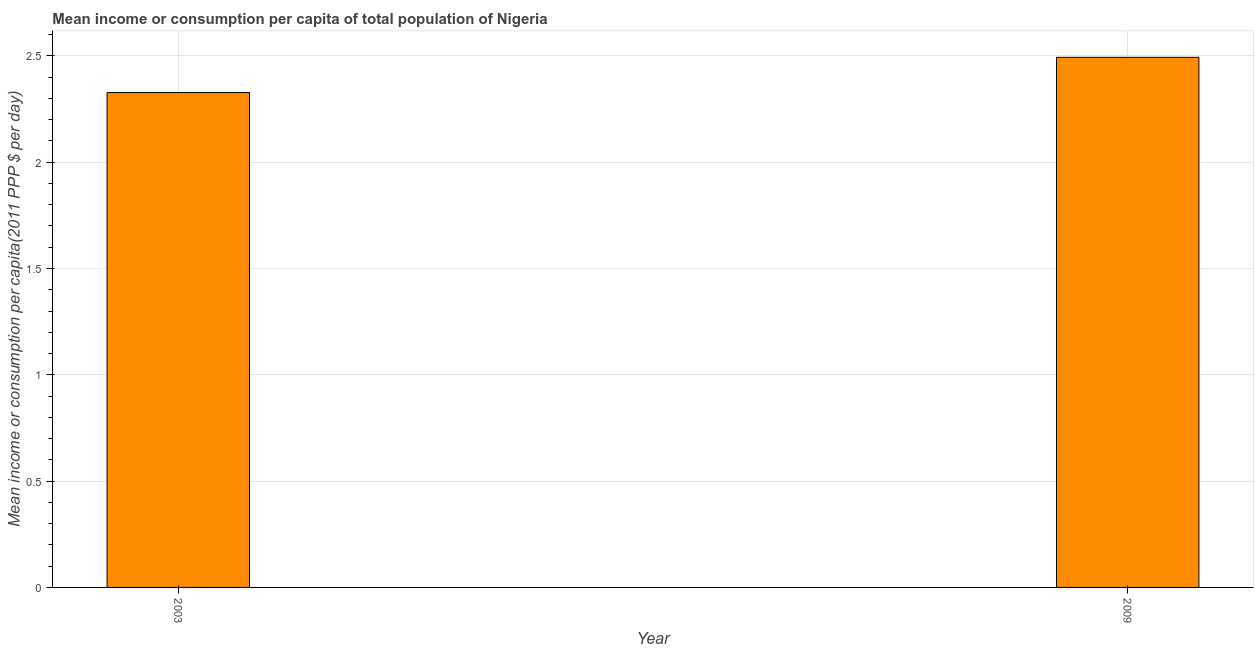What is the title of the graph?
Offer a terse response. Mean income or consumption per capita of total population of Nigeria. What is the label or title of the X-axis?
Make the answer very short. Year. What is the label or title of the Y-axis?
Provide a short and direct response. Mean income or consumption per capita(2011 PPP $ per day). What is the mean income or consumption in 2003?
Your answer should be compact. 2.33. Across all years, what is the maximum mean income or consumption?
Offer a very short reply. 2.49. Across all years, what is the minimum mean income or consumption?
Your response must be concise. 2.33. In which year was the mean income or consumption maximum?
Provide a short and direct response. 2009. In which year was the mean income or consumption minimum?
Offer a very short reply. 2003. What is the sum of the mean income or consumption?
Keep it short and to the point. 4.82. What is the difference between the mean income or consumption in 2003 and 2009?
Ensure brevity in your answer.  -0.17. What is the average mean income or consumption per year?
Keep it short and to the point. 2.41. What is the median mean income or consumption?
Offer a very short reply. 2.41. What is the ratio of the mean income or consumption in 2003 to that in 2009?
Offer a terse response. 0.93. In how many years, is the mean income or consumption greater than the average mean income or consumption taken over all years?
Your answer should be very brief. 1. How many bars are there?
Give a very brief answer. 2. Are all the bars in the graph horizontal?
Offer a terse response. No. How many years are there in the graph?
Ensure brevity in your answer.  2. What is the Mean income or consumption per capita(2011 PPP $ per day) in 2003?
Give a very brief answer. 2.33. What is the Mean income or consumption per capita(2011 PPP $ per day) of 2009?
Your answer should be very brief. 2.49. What is the difference between the Mean income or consumption per capita(2011 PPP $ per day) in 2003 and 2009?
Offer a terse response. -0.17. What is the ratio of the Mean income or consumption per capita(2011 PPP $ per day) in 2003 to that in 2009?
Your response must be concise. 0.93. 